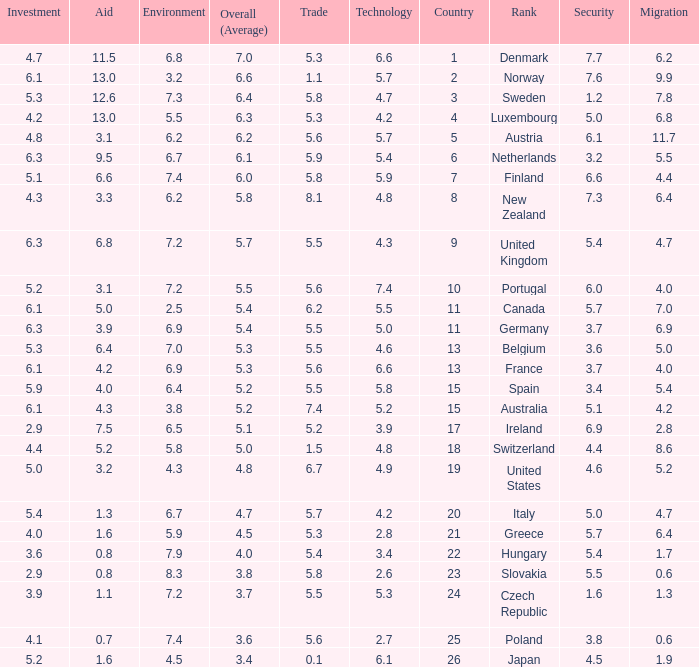What is the environment rating of the country with an overall average rating of 4.7? 6.7. 